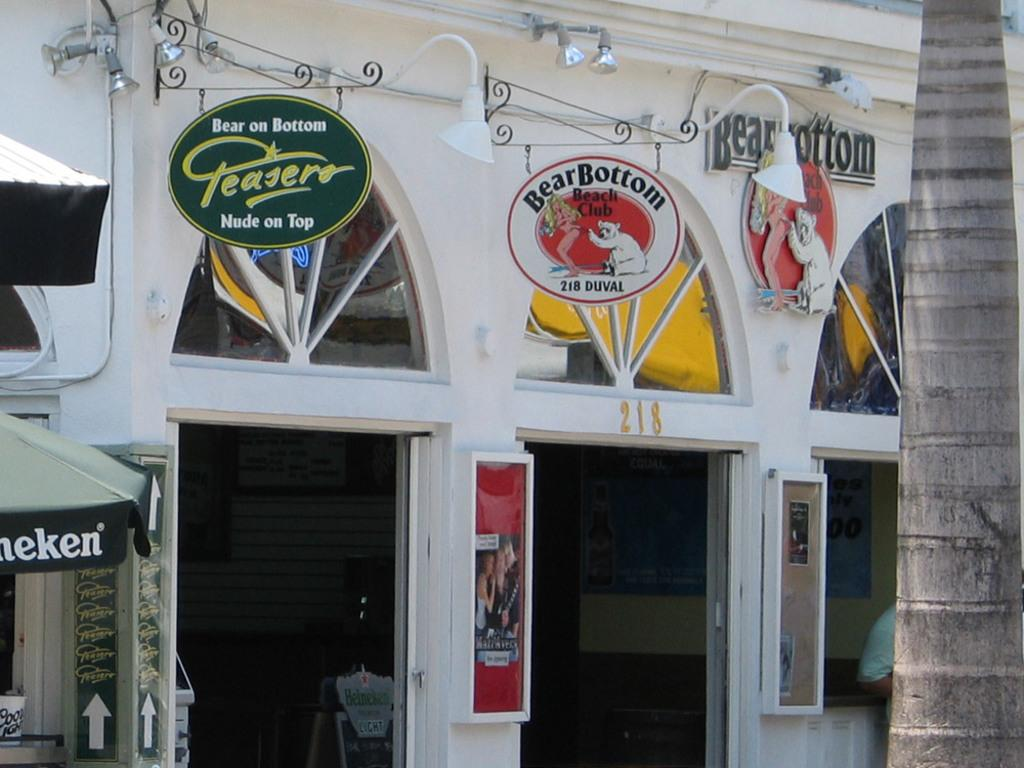What type of structure is in the image? There is a building in the image. What color is the building? The building is white. What is attached to the building? There are boards on the building. What is located to the right of the building? There is a tree to the right of the building. What is situated to the left of the building? There is a small tent to the left of the building. What type of breakfast is being served in the image? There is no breakfast present in the image; it features a building with boards, a tree, and a small tent. What is the topic of the discussion taking place in the image? There is no discussion taking place in the image; it is a static scene featuring a building, boards, a tree, and a small tent. 